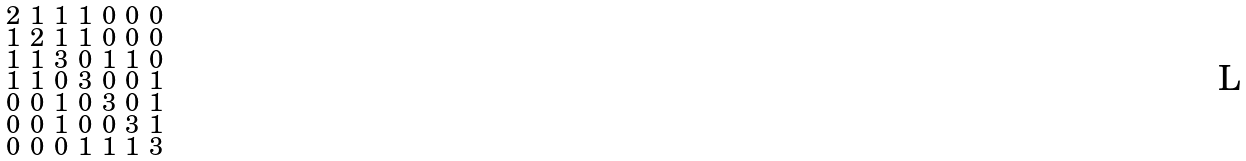Convert formula to latex. <formula><loc_0><loc_0><loc_500><loc_500>\begin{smallmatrix} 2 & 1 & 1 & 1 & 0 & 0 & 0 \\ 1 & 2 & 1 & 1 & 0 & 0 & 0 \\ 1 & 1 & 3 & 0 & 1 & 1 & 0 \\ 1 & 1 & 0 & 3 & 0 & 0 & 1 \\ 0 & 0 & 1 & 0 & 3 & 0 & 1 \\ 0 & 0 & 1 & 0 & 0 & 3 & 1 \\ 0 & 0 & 0 & 1 & 1 & 1 & 3 \end{smallmatrix}</formula> 